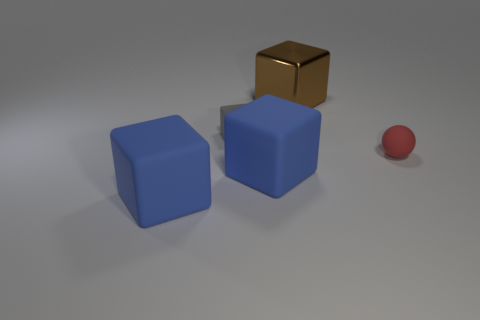Subtract all big metallic cubes. How many cubes are left? 3 Add 3 big things. How many objects exist? 8 Subtract all brown cubes. How many cubes are left? 3 Subtract 1 balls. How many balls are left? 0 Subtract all blocks. How many objects are left? 1 Subtract all gray balls. How many blue cubes are left? 2 Subtract all brown blocks. Subtract all purple rubber cylinders. How many objects are left? 4 Add 5 red objects. How many red objects are left? 6 Add 3 small red rubber objects. How many small red rubber objects exist? 4 Subtract 0 purple blocks. How many objects are left? 5 